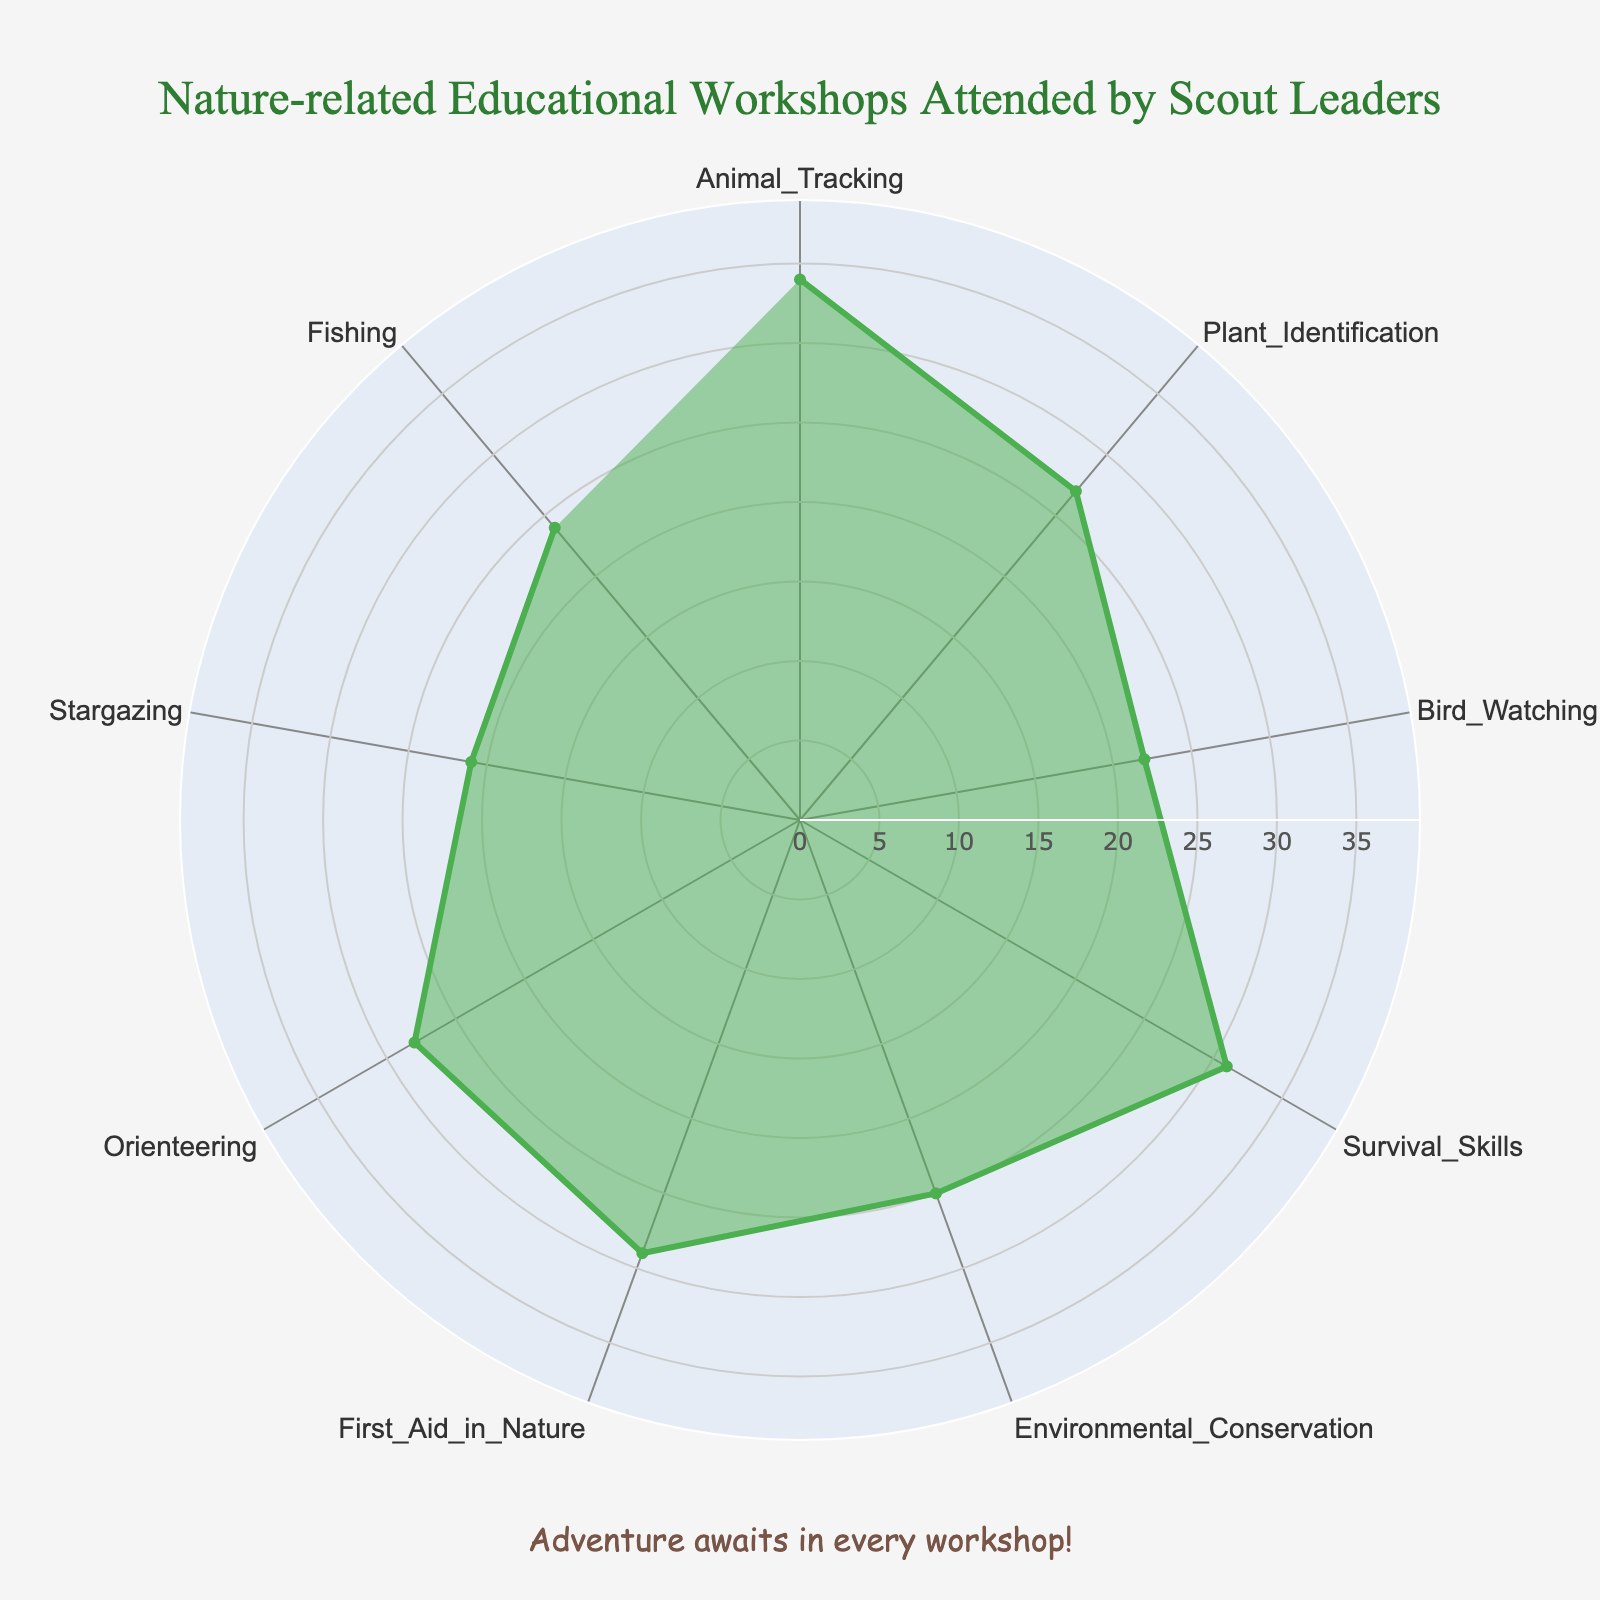What's the title of the chart? The title is usually placed at the top of the chart and is meant to summarize the content clearly.
Answer: "Nature-related Educational Workshops Attended by Scout Leaders" What is the workshop with the highest number of attendees? To identify the workshop with the highest number of attendees, look for the category with the largest value along the radial axis.
Answer: "Animal Tracking" How many attendees were at the Bird Watching workshop? Find the value corresponding to the Bird Watching category on the radar chart.
Answer: "22" Which workshop had fewer attendees: Plant Identification or Environmental Conservation? Compare the values for both workshops: Plant Identification (27) and Environmental Conservation (25).
Answer: "Environmental Conservation" What is the total number of attendees for the Survival Skills and Fishing workshops combined? Add the number of attendees for Survival Skills (31) and Fishing (24). 31 + 24 = 55.
Answer: "55" What is the average number of attendees across all workshops? Add all the attendees' numbers and divide by the number of workshops: (34 + 27 + 22 + 31 + 25 + 29 + 28 + 21 + 24) = 241, then 241/9.
Answer: "26.8" How many workshops had more than 25 attendees? Count the categories with values over 25: Animal Tracking (34), Survival Skills (31), First Aid in Nature (29), Orienteering (28), and Plant Identification (27). There are five such workshops.
Answer: "5" What is the difference in attendees between Stargazing and Orienteering workshops? Subtract the number of attendees for Stargazing (21) from the number of attendees for Orienteering (28). 28 - 21 = 7.
Answer: "7" Which workshop had the closest number of attendees to the average number of attendees? First, calculate the average, which is 26.8. Then, compare each workshop's attendees to this average:
Animal Tracking (34 - 26.8 = 7.2)
Plant Identification (27 - 26.8 = 0.2)
Bird Watching (26.8 - 22 = 4.8)
Survival Skills (31 - 26.8 = 4.2)
Environmental Conservation (26.8 - 25 = 1.8)
First Aid in Nature (29 - 26.8 = 2.2)
Orienteering (28 - 26.8 = 1.2)
Stargazing (26.8 - 21 = 5.8)
Fishing (26.8 - 24 = 2.8).
Plant Identification has the smallest difference of 0.2.
Answer: "Plant Identification" Which workshop categories have less than 25 attendees? Identify the categories with values less than 25: Bird Watching (22), Stargazing (21), and Fishing (24).
Answer: "Bird Watching, Stargazing, Fishing" 